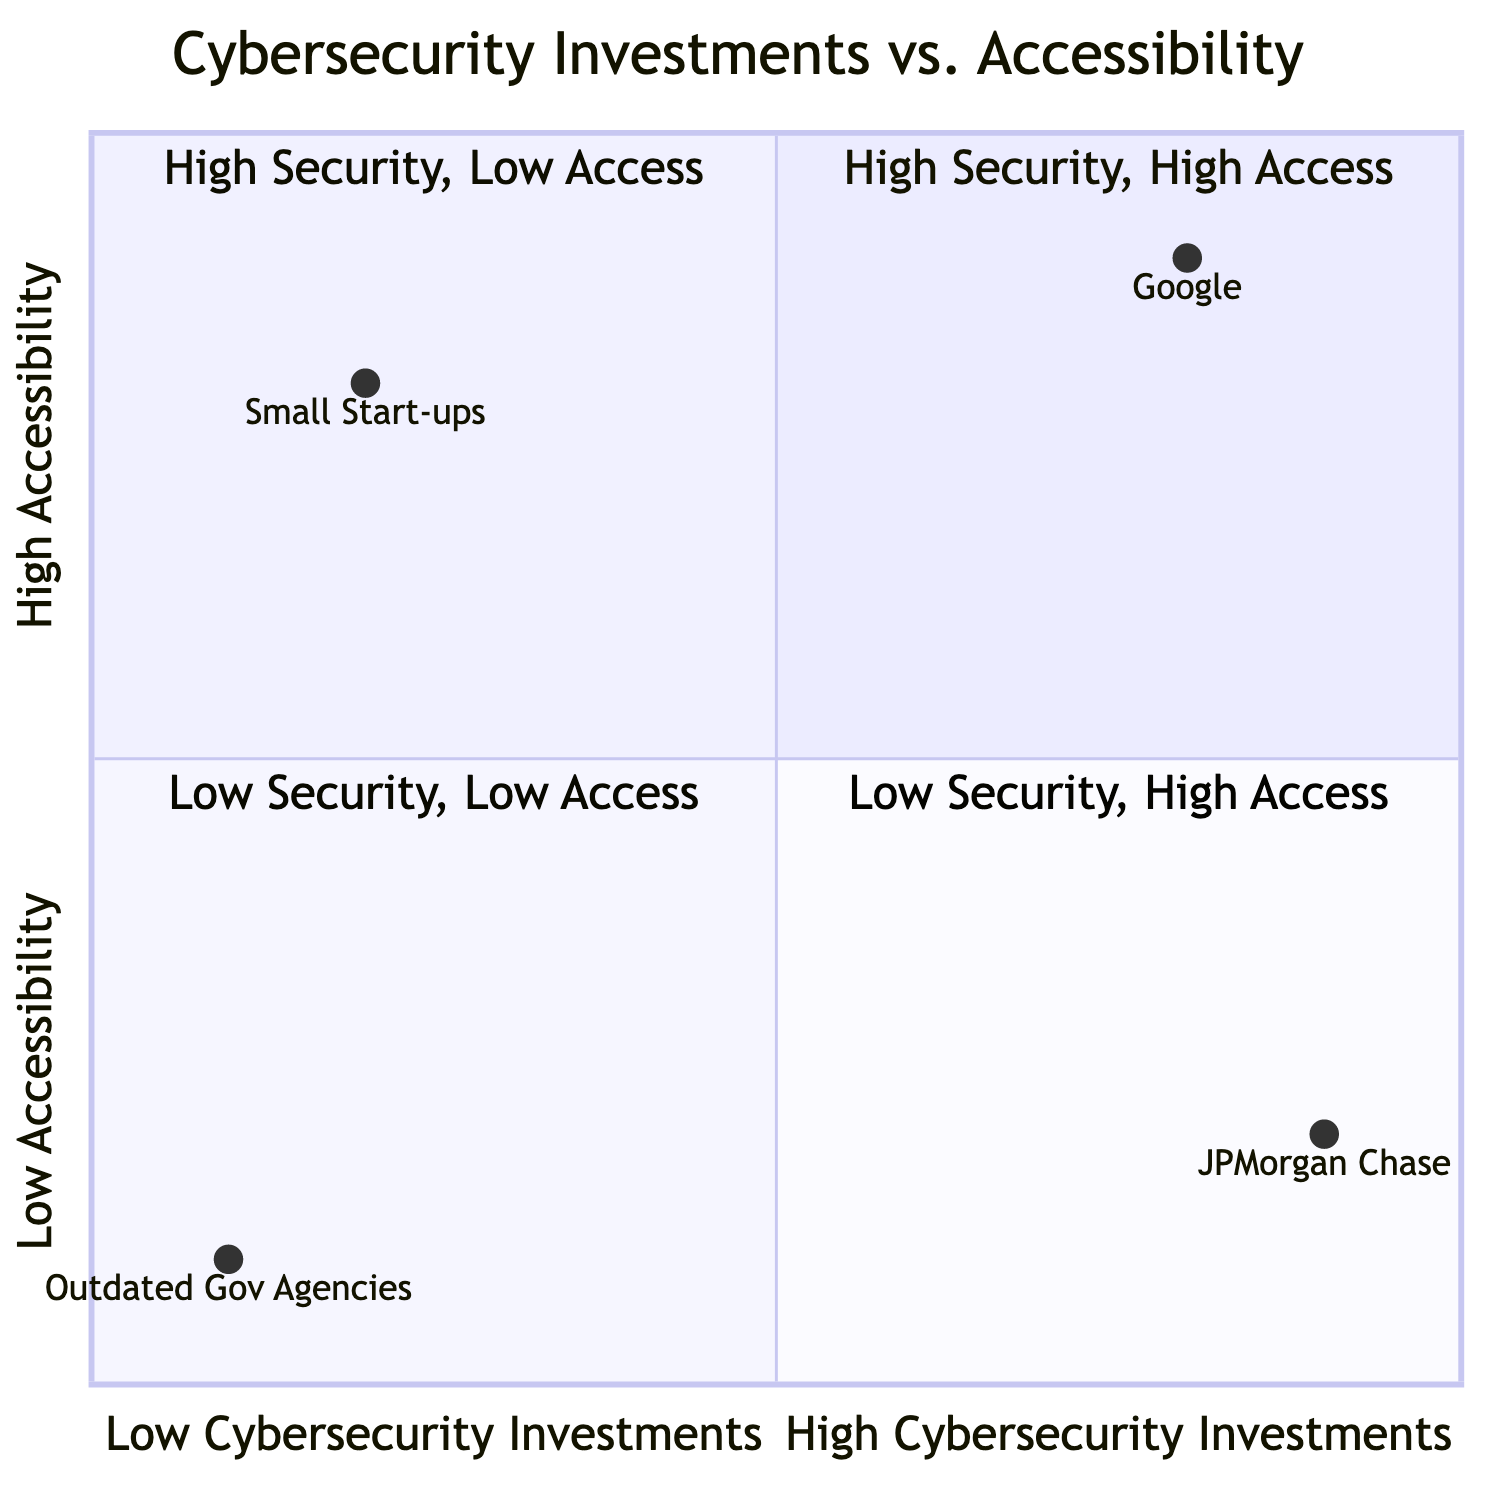What organization falls in the "High Security, High Access" quadrant? The "High Security, High Access" quadrant is where organizations balance strong cybersecurity measures with robust open internet access. According to the diagram, Google is identified as the organization in this quadrant.
Answer: Google Which company has the lowest accessibility score? To determine the lowest accessibility score, we look at the y-axis values for each organization. JPMorgan Chase has a score of 0.2, which is the lowest among the listed organizations.
Answer: JPMorgan Chase How many organizations are in the "Low Security, High Access" quadrant? The "Low Security, High Access" quadrant features organizations that have minimal cybersecurity protections but maintain high levels of open internet access. According to the diagram, one organization, small start-ups, is placed in this quadrant.
Answer: 1 What are the accessibility and cybersecurity investment scores for Outdated Government Agencies? We check the coordinates provided in the diagram for Outdated Government Agencies. According to the diagram, their scores are at (0.1, 0.1), which means their cybersecurity investment is 0.1 and accessibility is also 0.1.
Answer: 0.1, 0.1 Which organization is found in the "Low Security, Low Access" quadrant? The "Low Security, Low Access" quadrant is characterized by entities that neither invest significantly in cybersecurity nor prioritize internet accessibility. The diagram indicates that Outdated Government Agencies are represented in this quadrant.
Answer: Outdated Government Agencies What is the accessibility score for Google? We find the accessibility score by checking the y-coordinate for Google, which according to the diagram is 0.9, indicating high accessibility.
Answer: 0.9 Which organization has high security investments but low accessibility? The organization that primarily focuses on stringent security protocols at the expense of accessibility is categorized in the "High Security, Low Access" quadrant. The diagram identifies JPMorgan Chase as fitting this description.
Answer: JPMorgan Chase What scores place Small Start-ups in the "Low Security, High Access" quadrant? To determine the placement of Small Start-ups in the "Low Security, High Access" quadrant, we check their coordinates. They have scores of 0.2 for cybersecurity investment and 0.8 for accessibility, fitting the criteria for this quadrant.
Answer: 0.2, 0.8 